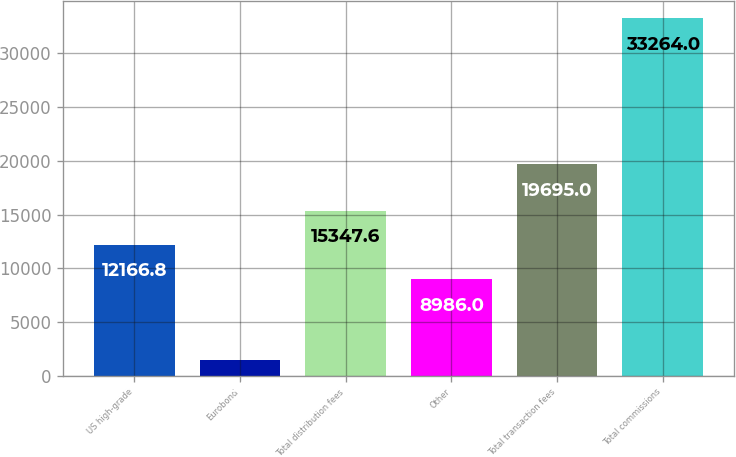Convert chart to OTSL. <chart><loc_0><loc_0><loc_500><loc_500><bar_chart><fcel>US high-grade<fcel>Eurobond<fcel>Total distribution fees<fcel>Other<fcel>Total transaction fees<fcel>Total commissions<nl><fcel>12166.8<fcel>1456<fcel>15347.6<fcel>8986<fcel>19695<fcel>33264<nl></chart> 